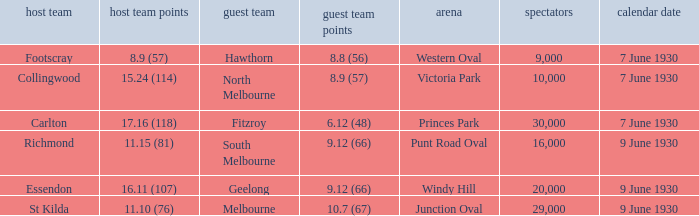Could you parse the entire table? {'header': ['host team', 'host team points', 'guest team', 'guest team points', 'arena', 'spectators', 'calendar date'], 'rows': [['Footscray', '8.9 (57)', 'Hawthorn', '8.8 (56)', 'Western Oval', '9,000', '7 June 1930'], ['Collingwood', '15.24 (114)', 'North Melbourne', '8.9 (57)', 'Victoria Park', '10,000', '7 June 1930'], ['Carlton', '17.16 (118)', 'Fitzroy', '6.12 (48)', 'Princes Park', '30,000', '7 June 1930'], ['Richmond', '11.15 (81)', 'South Melbourne', '9.12 (66)', 'Punt Road Oval', '16,000', '9 June 1930'], ['Essendon', '16.11 (107)', 'Geelong', '9.12 (66)', 'Windy Hill', '20,000', '9 June 1930'], ['St Kilda', '11.10 (76)', 'Melbourne', '10.7 (67)', 'Junction Oval', '29,000', '9 June 1930']]} What away team played Footscray? Hawthorn. 